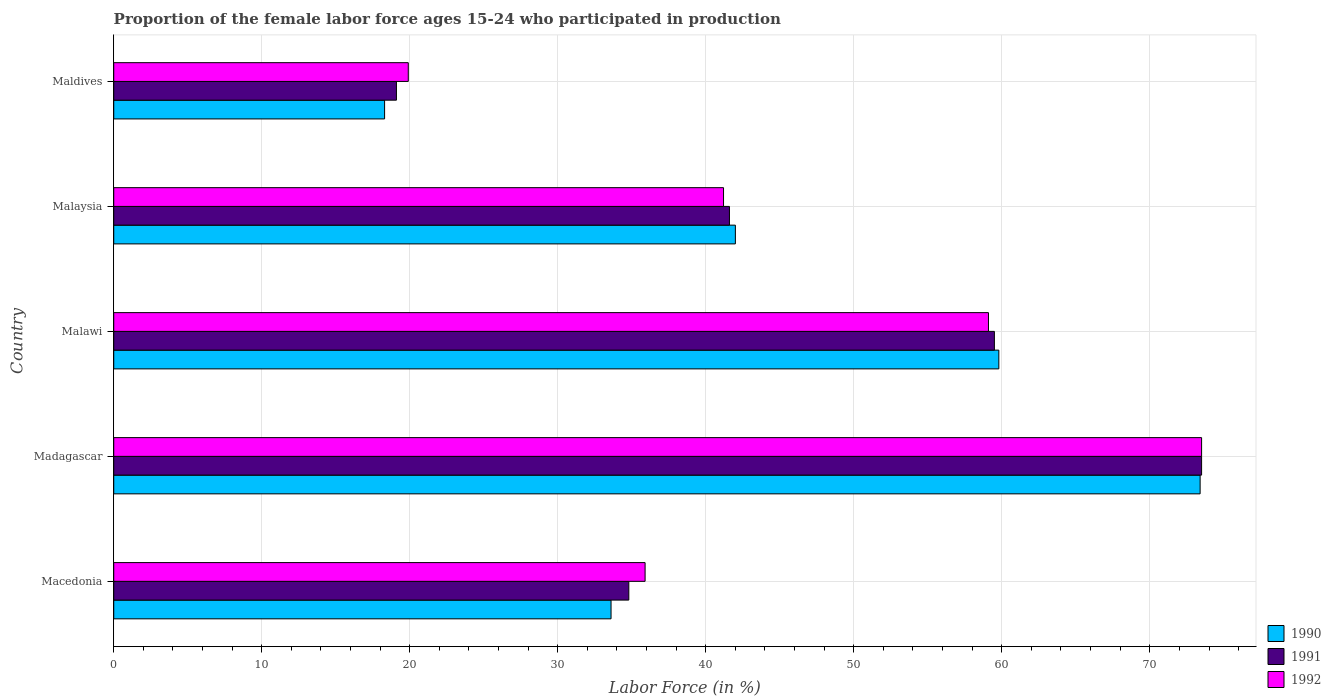What is the label of the 4th group of bars from the top?
Your answer should be compact. Madagascar. What is the proportion of the female labor force who participated in production in 1990 in Madagascar?
Provide a succinct answer. 73.4. Across all countries, what is the maximum proportion of the female labor force who participated in production in 1992?
Keep it short and to the point. 73.5. Across all countries, what is the minimum proportion of the female labor force who participated in production in 1990?
Offer a terse response. 18.3. In which country was the proportion of the female labor force who participated in production in 1990 maximum?
Provide a short and direct response. Madagascar. In which country was the proportion of the female labor force who participated in production in 1992 minimum?
Your answer should be compact. Maldives. What is the total proportion of the female labor force who participated in production in 1990 in the graph?
Ensure brevity in your answer.  227.1. What is the difference between the proportion of the female labor force who participated in production in 1990 in Malawi and that in Maldives?
Your response must be concise. 41.5. What is the difference between the proportion of the female labor force who participated in production in 1991 in Malawi and the proportion of the female labor force who participated in production in 1990 in Macedonia?
Keep it short and to the point. 25.9. What is the average proportion of the female labor force who participated in production in 1992 per country?
Offer a terse response. 45.92. What is the difference between the proportion of the female labor force who participated in production in 1992 and proportion of the female labor force who participated in production in 1990 in Madagascar?
Ensure brevity in your answer.  0.1. In how many countries, is the proportion of the female labor force who participated in production in 1991 greater than 64 %?
Make the answer very short. 1. What is the ratio of the proportion of the female labor force who participated in production in 1992 in Macedonia to that in Malaysia?
Offer a terse response. 0.87. Is the proportion of the female labor force who participated in production in 1991 in Macedonia less than that in Madagascar?
Give a very brief answer. Yes. Is the difference between the proportion of the female labor force who participated in production in 1992 in Malawi and Maldives greater than the difference between the proportion of the female labor force who participated in production in 1990 in Malawi and Maldives?
Provide a succinct answer. No. What is the difference between the highest and the lowest proportion of the female labor force who participated in production in 1990?
Your response must be concise. 55.1. In how many countries, is the proportion of the female labor force who participated in production in 1992 greater than the average proportion of the female labor force who participated in production in 1992 taken over all countries?
Your answer should be very brief. 2. Is the sum of the proportion of the female labor force who participated in production in 1990 in Madagascar and Malaysia greater than the maximum proportion of the female labor force who participated in production in 1992 across all countries?
Your answer should be compact. Yes. What does the 1st bar from the top in Madagascar represents?
Offer a very short reply. 1992. Is it the case that in every country, the sum of the proportion of the female labor force who participated in production in 1991 and proportion of the female labor force who participated in production in 1992 is greater than the proportion of the female labor force who participated in production in 1990?
Keep it short and to the point. Yes. Are all the bars in the graph horizontal?
Your response must be concise. Yes. Where does the legend appear in the graph?
Your answer should be very brief. Bottom right. How many legend labels are there?
Offer a very short reply. 3. How are the legend labels stacked?
Offer a terse response. Vertical. What is the title of the graph?
Your answer should be very brief. Proportion of the female labor force ages 15-24 who participated in production. Does "1988" appear as one of the legend labels in the graph?
Keep it short and to the point. No. What is the label or title of the Y-axis?
Your answer should be compact. Country. What is the Labor Force (in %) of 1990 in Macedonia?
Provide a succinct answer. 33.6. What is the Labor Force (in %) of 1991 in Macedonia?
Provide a succinct answer. 34.8. What is the Labor Force (in %) of 1992 in Macedonia?
Your response must be concise. 35.9. What is the Labor Force (in %) in 1990 in Madagascar?
Your answer should be compact. 73.4. What is the Labor Force (in %) of 1991 in Madagascar?
Provide a short and direct response. 73.5. What is the Labor Force (in %) of 1992 in Madagascar?
Keep it short and to the point. 73.5. What is the Labor Force (in %) of 1990 in Malawi?
Offer a very short reply. 59.8. What is the Labor Force (in %) in 1991 in Malawi?
Keep it short and to the point. 59.5. What is the Labor Force (in %) of 1992 in Malawi?
Your answer should be very brief. 59.1. What is the Labor Force (in %) in 1990 in Malaysia?
Ensure brevity in your answer.  42. What is the Labor Force (in %) in 1991 in Malaysia?
Offer a terse response. 41.6. What is the Labor Force (in %) in 1992 in Malaysia?
Give a very brief answer. 41.2. What is the Labor Force (in %) of 1990 in Maldives?
Offer a very short reply. 18.3. What is the Labor Force (in %) in 1991 in Maldives?
Make the answer very short. 19.1. What is the Labor Force (in %) in 1992 in Maldives?
Your response must be concise. 19.9. Across all countries, what is the maximum Labor Force (in %) in 1990?
Make the answer very short. 73.4. Across all countries, what is the maximum Labor Force (in %) in 1991?
Offer a very short reply. 73.5. Across all countries, what is the maximum Labor Force (in %) in 1992?
Provide a short and direct response. 73.5. Across all countries, what is the minimum Labor Force (in %) of 1990?
Ensure brevity in your answer.  18.3. Across all countries, what is the minimum Labor Force (in %) of 1991?
Provide a short and direct response. 19.1. Across all countries, what is the minimum Labor Force (in %) of 1992?
Ensure brevity in your answer.  19.9. What is the total Labor Force (in %) of 1990 in the graph?
Your response must be concise. 227.1. What is the total Labor Force (in %) of 1991 in the graph?
Keep it short and to the point. 228.5. What is the total Labor Force (in %) of 1992 in the graph?
Offer a terse response. 229.6. What is the difference between the Labor Force (in %) in 1990 in Macedonia and that in Madagascar?
Provide a succinct answer. -39.8. What is the difference between the Labor Force (in %) of 1991 in Macedonia and that in Madagascar?
Give a very brief answer. -38.7. What is the difference between the Labor Force (in %) of 1992 in Macedonia and that in Madagascar?
Your answer should be very brief. -37.6. What is the difference between the Labor Force (in %) of 1990 in Macedonia and that in Malawi?
Provide a short and direct response. -26.2. What is the difference between the Labor Force (in %) of 1991 in Macedonia and that in Malawi?
Offer a very short reply. -24.7. What is the difference between the Labor Force (in %) in 1992 in Macedonia and that in Malawi?
Keep it short and to the point. -23.2. What is the difference between the Labor Force (in %) of 1991 in Macedonia and that in Malaysia?
Offer a very short reply. -6.8. What is the difference between the Labor Force (in %) in 1992 in Macedonia and that in Malaysia?
Offer a terse response. -5.3. What is the difference between the Labor Force (in %) in 1992 in Macedonia and that in Maldives?
Offer a terse response. 16. What is the difference between the Labor Force (in %) in 1990 in Madagascar and that in Malawi?
Make the answer very short. 13.6. What is the difference between the Labor Force (in %) of 1991 in Madagascar and that in Malawi?
Make the answer very short. 14. What is the difference between the Labor Force (in %) in 1992 in Madagascar and that in Malawi?
Provide a succinct answer. 14.4. What is the difference between the Labor Force (in %) in 1990 in Madagascar and that in Malaysia?
Offer a terse response. 31.4. What is the difference between the Labor Force (in %) in 1991 in Madagascar and that in Malaysia?
Provide a short and direct response. 31.9. What is the difference between the Labor Force (in %) in 1992 in Madagascar and that in Malaysia?
Provide a succinct answer. 32.3. What is the difference between the Labor Force (in %) in 1990 in Madagascar and that in Maldives?
Offer a very short reply. 55.1. What is the difference between the Labor Force (in %) of 1991 in Madagascar and that in Maldives?
Offer a very short reply. 54.4. What is the difference between the Labor Force (in %) in 1992 in Madagascar and that in Maldives?
Offer a terse response. 53.6. What is the difference between the Labor Force (in %) in 1990 in Malawi and that in Maldives?
Ensure brevity in your answer.  41.5. What is the difference between the Labor Force (in %) of 1991 in Malawi and that in Maldives?
Your response must be concise. 40.4. What is the difference between the Labor Force (in %) in 1992 in Malawi and that in Maldives?
Offer a terse response. 39.2. What is the difference between the Labor Force (in %) in 1990 in Malaysia and that in Maldives?
Your answer should be very brief. 23.7. What is the difference between the Labor Force (in %) in 1991 in Malaysia and that in Maldives?
Offer a terse response. 22.5. What is the difference between the Labor Force (in %) of 1992 in Malaysia and that in Maldives?
Offer a terse response. 21.3. What is the difference between the Labor Force (in %) of 1990 in Macedonia and the Labor Force (in %) of 1991 in Madagascar?
Your answer should be very brief. -39.9. What is the difference between the Labor Force (in %) in 1990 in Macedonia and the Labor Force (in %) in 1992 in Madagascar?
Your answer should be compact. -39.9. What is the difference between the Labor Force (in %) of 1991 in Macedonia and the Labor Force (in %) of 1992 in Madagascar?
Provide a short and direct response. -38.7. What is the difference between the Labor Force (in %) of 1990 in Macedonia and the Labor Force (in %) of 1991 in Malawi?
Offer a very short reply. -25.9. What is the difference between the Labor Force (in %) of 1990 in Macedonia and the Labor Force (in %) of 1992 in Malawi?
Ensure brevity in your answer.  -25.5. What is the difference between the Labor Force (in %) of 1991 in Macedonia and the Labor Force (in %) of 1992 in Malawi?
Your response must be concise. -24.3. What is the difference between the Labor Force (in %) of 1990 in Macedonia and the Labor Force (in %) of 1991 in Malaysia?
Give a very brief answer. -8. What is the difference between the Labor Force (in %) of 1991 in Macedonia and the Labor Force (in %) of 1992 in Malaysia?
Your answer should be compact. -6.4. What is the difference between the Labor Force (in %) of 1990 in Macedonia and the Labor Force (in %) of 1991 in Maldives?
Ensure brevity in your answer.  14.5. What is the difference between the Labor Force (in %) of 1991 in Macedonia and the Labor Force (in %) of 1992 in Maldives?
Your answer should be very brief. 14.9. What is the difference between the Labor Force (in %) in 1990 in Madagascar and the Labor Force (in %) in 1991 in Malaysia?
Your response must be concise. 31.8. What is the difference between the Labor Force (in %) of 1990 in Madagascar and the Labor Force (in %) of 1992 in Malaysia?
Your answer should be compact. 32.2. What is the difference between the Labor Force (in %) of 1991 in Madagascar and the Labor Force (in %) of 1992 in Malaysia?
Offer a terse response. 32.3. What is the difference between the Labor Force (in %) in 1990 in Madagascar and the Labor Force (in %) in 1991 in Maldives?
Give a very brief answer. 54.3. What is the difference between the Labor Force (in %) of 1990 in Madagascar and the Labor Force (in %) of 1992 in Maldives?
Provide a succinct answer. 53.5. What is the difference between the Labor Force (in %) of 1991 in Madagascar and the Labor Force (in %) of 1992 in Maldives?
Your answer should be compact. 53.6. What is the difference between the Labor Force (in %) of 1990 in Malawi and the Labor Force (in %) of 1991 in Malaysia?
Provide a short and direct response. 18.2. What is the difference between the Labor Force (in %) of 1991 in Malawi and the Labor Force (in %) of 1992 in Malaysia?
Make the answer very short. 18.3. What is the difference between the Labor Force (in %) of 1990 in Malawi and the Labor Force (in %) of 1991 in Maldives?
Ensure brevity in your answer.  40.7. What is the difference between the Labor Force (in %) in 1990 in Malawi and the Labor Force (in %) in 1992 in Maldives?
Provide a succinct answer. 39.9. What is the difference between the Labor Force (in %) in 1991 in Malawi and the Labor Force (in %) in 1992 in Maldives?
Your answer should be very brief. 39.6. What is the difference between the Labor Force (in %) in 1990 in Malaysia and the Labor Force (in %) in 1991 in Maldives?
Your answer should be compact. 22.9. What is the difference between the Labor Force (in %) of 1990 in Malaysia and the Labor Force (in %) of 1992 in Maldives?
Ensure brevity in your answer.  22.1. What is the difference between the Labor Force (in %) of 1991 in Malaysia and the Labor Force (in %) of 1992 in Maldives?
Offer a terse response. 21.7. What is the average Labor Force (in %) in 1990 per country?
Provide a succinct answer. 45.42. What is the average Labor Force (in %) in 1991 per country?
Your response must be concise. 45.7. What is the average Labor Force (in %) of 1992 per country?
Give a very brief answer. 45.92. What is the difference between the Labor Force (in %) of 1991 and Labor Force (in %) of 1992 in Macedonia?
Your answer should be compact. -1.1. What is the difference between the Labor Force (in %) in 1991 and Labor Force (in %) in 1992 in Madagascar?
Give a very brief answer. 0. What is the difference between the Labor Force (in %) in 1990 and Labor Force (in %) in 1991 in Malawi?
Ensure brevity in your answer.  0.3. What is the difference between the Labor Force (in %) in 1991 and Labor Force (in %) in 1992 in Malawi?
Your answer should be very brief. 0.4. What is the difference between the Labor Force (in %) of 1991 and Labor Force (in %) of 1992 in Malaysia?
Make the answer very short. 0.4. What is the difference between the Labor Force (in %) in 1991 and Labor Force (in %) in 1992 in Maldives?
Your response must be concise. -0.8. What is the ratio of the Labor Force (in %) in 1990 in Macedonia to that in Madagascar?
Provide a succinct answer. 0.46. What is the ratio of the Labor Force (in %) in 1991 in Macedonia to that in Madagascar?
Your answer should be very brief. 0.47. What is the ratio of the Labor Force (in %) in 1992 in Macedonia to that in Madagascar?
Give a very brief answer. 0.49. What is the ratio of the Labor Force (in %) in 1990 in Macedonia to that in Malawi?
Offer a very short reply. 0.56. What is the ratio of the Labor Force (in %) in 1991 in Macedonia to that in Malawi?
Make the answer very short. 0.58. What is the ratio of the Labor Force (in %) in 1992 in Macedonia to that in Malawi?
Provide a short and direct response. 0.61. What is the ratio of the Labor Force (in %) of 1991 in Macedonia to that in Malaysia?
Keep it short and to the point. 0.84. What is the ratio of the Labor Force (in %) in 1992 in Macedonia to that in Malaysia?
Your answer should be compact. 0.87. What is the ratio of the Labor Force (in %) of 1990 in Macedonia to that in Maldives?
Provide a short and direct response. 1.84. What is the ratio of the Labor Force (in %) of 1991 in Macedonia to that in Maldives?
Ensure brevity in your answer.  1.82. What is the ratio of the Labor Force (in %) in 1992 in Macedonia to that in Maldives?
Make the answer very short. 1.8. What is the ratio of the Labor Force (in %) in 1990 in Madagascar to that in Malawi?
Your response must be concise. 1.23. What is the ratio of the Labor Force (in %) in 1991 in Madagascar to that in Malawi?
Your answer should be very brief. 1.24. What is the ratio of the Labor Force (in %) of 1992 in Madagascar to that in Malawi?
Offer a terse response. 1.24. What is the ratio of the Labor Force (in %) in 1990 in Madagascar to that in Malaysia?
Your response must be concise. 1.75. What is the ratio of the Labor Force (in %) of 1991 in Madagascar to that in Malaysia?
Keep it short and to the point. 1.77. What is the ratio of the Labor Force (in %) in 1992 in Madagascar to that in Malaysia?
Your response must be concise. 1.78. What is the ratio of the Labor Force (in %) of 1990 in Madagascar to that in Maldives?
Your answer should be compact. 4.01. What is the ratio of the Labor Force (in %) in 1991 in Madagascar to that in Maldives?
Your response must be concise. 3.85. What is the ratio of the Labor Force (in %) of 1992 in Madagascar to that in Maldives?
Give a very brief answer. 3.69. What is the ratio of the Labor Force (in %) in 1990 in Malawi to that in Malaysia?
Offer a very short reply. 1.42. What is the ratio of the Labor Force (in %) in 1991 in Malawi to that in Malaysia?
Offer a terse response. 1.43. What is the ratio of the Labor Force (in %) in 1992 in Malawi to that in Malaysia?
Your answer should be very brief. 1.43. What is the ratio of the Labor Force (in %) of 1990 in Malawi to that in Maldives?
Make the answer very short. 3.27. What is the ratio of the Labor Force (in %) in 1991 in Malawi to that in Maldives?
Keep it short and to the point. 3.12. What is the ratio of the Labor Force (in %) of 1992 in Malawi to that in Maldives?
Keep it short and to the point. 2.97. What is the ratio of the Labor Force (in %) of 1990 in Malaysia to that in Maldives?
Your response must be concise. 2.3. What is the ratio of the Labor Force (in %) in 1991 in Malaysia to that in Maldives?
Your answer should be very brief. 2.18. What is the ratio of the Labor Force (in %) in 1992 in Malaysia to that in Maldives?
Your answer should be compact. 2.07. What is the difference between the highest and the second highest Labor Force (in %) of 1990?
Ensure brevity in your answer.  13.6. What is the difference between the highest and the lowest Labor Force (in %) in 1990?
Offer a very short reply. 55.1. What is the difference between the highest and the lowest Labor Force (in %) in 1991?
Keep it short and to the point. 54.4. What is the difference between the highest and the lowest Labor Force (in %) of 1992?
Give a very brief answer. 53.6. 